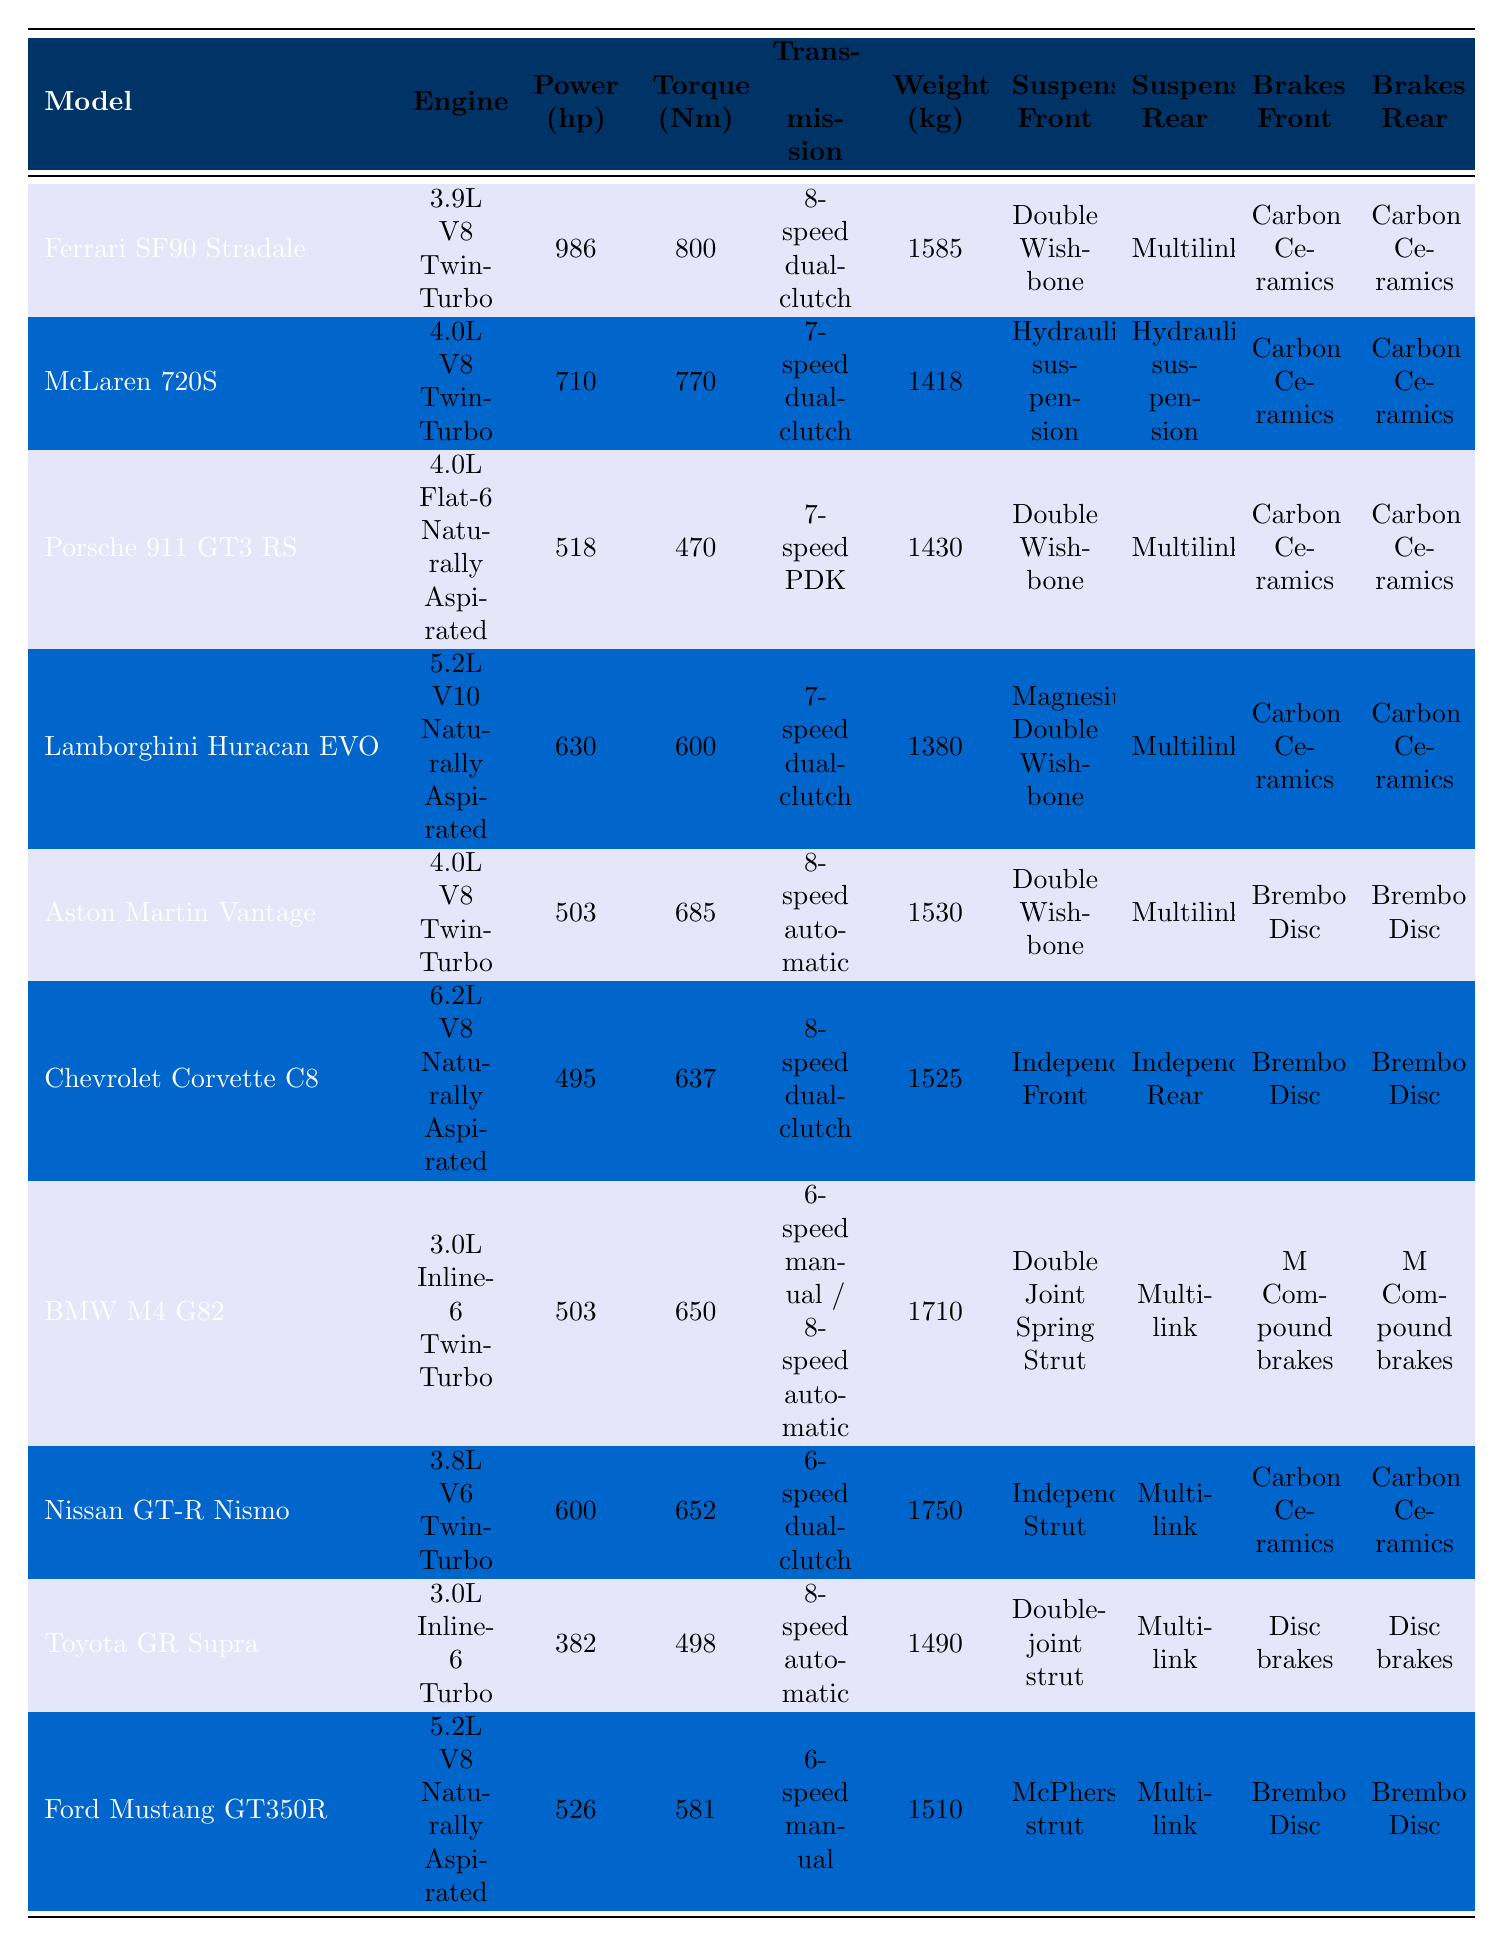What is the engine type of the McLaren 720S? By inspecting the row for the McLaren 720S, the engine type specified is "4.0L V8 Twin-Turbo".
Answer: 4.0L V8 Twin-Turbo Which model has the highest power output? By reviewing the power output column, the Ferrari SF90 Stradale with 986 hp has the highest power compared to other models listed.
Answer: Ferrari SF90 Stradale Is the Aston Martin Vantage lighter than the Lamborghini Huracan EVO? The Aston Martin Vantage weighs 1530 kg, while the Lamborghini Huracan EVO weighs 1380 kg. Since 1380 kg is lighter than 1530 kg, the statement is true.
Answer: Yes What is the average torque of the Nissan GT-R Nismo and the Toyota GR Supra? The torque of the Nissan GT-R Nismo is 652 Nm, and for the Toyota GR Supra, it is 498 Nm. The sum is 652 + 498 = 1150 Nm, and there are 2 models, so the average torque is 1150 / 2 = 575 Nm.
Answer: 575 Nm Do any models use Carbon Ceramic brakes? By scanning the brakes column, multiple models, including the Ferrari SF90 Stradale, McLaren 720S, Porsche 911 GT3 RS, Lamborghini Huracan EVO, and Nissan GT-R Nismo, have Carbon Ceramic brakes. Thus, the answer is true.
Answer: Yes Which model has the highest weight, and what is its weight? Checking the weight column, the BMW M4 G82 weighs 1710 kg, which is the highest compared to the other models.
Answer: BMW M4 G82, 1710 kg How much more power does the Ferrari SF90 Stradale have compared to the Ford Mustang GT350R? The Ferrari SF90 Stradale has 986 hp and the Ford Mustang GT350R has 526 hp. The difference is 986 – 526 = 460 hp.
Answer: 460 hp What type of suspension does the Chevrolet Corvette C8 have for the rear? In the row for the Chevrolet Corvette C8, it shows "Independent Rear" for the rear suspension type.
Answer: Independent Rear Which two models have the same brake type? By checking the brake types, the Aston Martin Vantage and Chevrolet Corvette C8 both use "Brembo Disc". Thus, these two models share the same brake type.
Answer: Aston Martin Vantage and Chevrolet Corvette C8 How much does the Porsche 911 GT3 RS weigh compared to the Ferrari SF90 Stradale? The Porsche 911 GT3 RS weighs 1430 kg, while the Ferrari SF90 Stradale weighs 1585 kg. The difference is 1585 – 1430 = 155 kg.
Answer: 155 kg lighter 